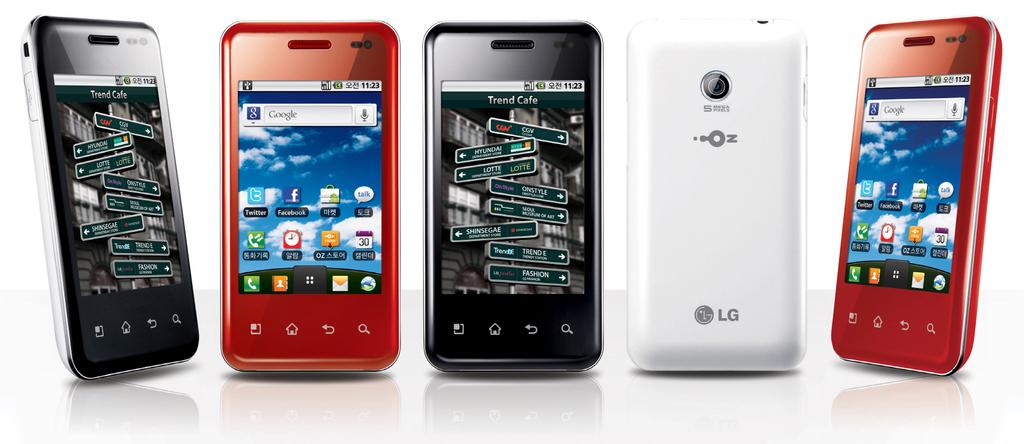What is the brand of these phones?
Your answer should be compact. Lg. Are these phones made by lg?
Your response must be concise. Yes. 